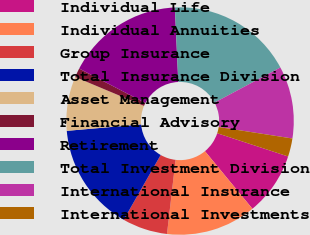Convert chart to OTSL. <chart><loc_0><loc_0><loc_500><loc_500><pie_chart><fcel>Individual Life<fcel>Individual Annuities<fcel>Group Insurance<fcel>Total Insurance Division<fcel>Asset Management<fcel>Financial Advisory<fcel>Retirement<fcel>Total Investment Division<fcel>International Insurance<fcel>International Investments<nl><fcel>8.98%<fcel>12.81%<fcel>6.42%<fcel>15.37%<fcel>7.7%<fcel>1.31%<fcel>16.64%<fcel>17.92%<fcel>10.26%<fcel>2.59%<nl></chart> 